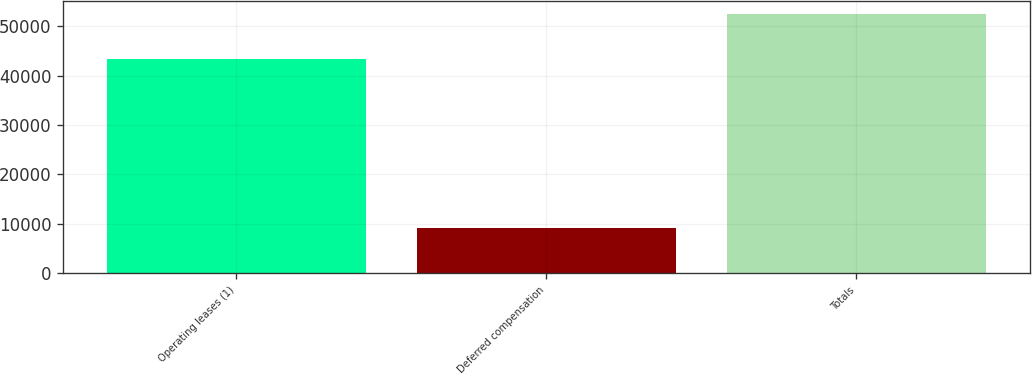<chart> <loc_0><loc_0><loc_500><loc_500><bar_chart><fcel>Operating leases (1)<fcel>Deferred compensation<fcel>Totals<nl><fcel>43428<fcel>9138<fcel>52566<nl></chart> 